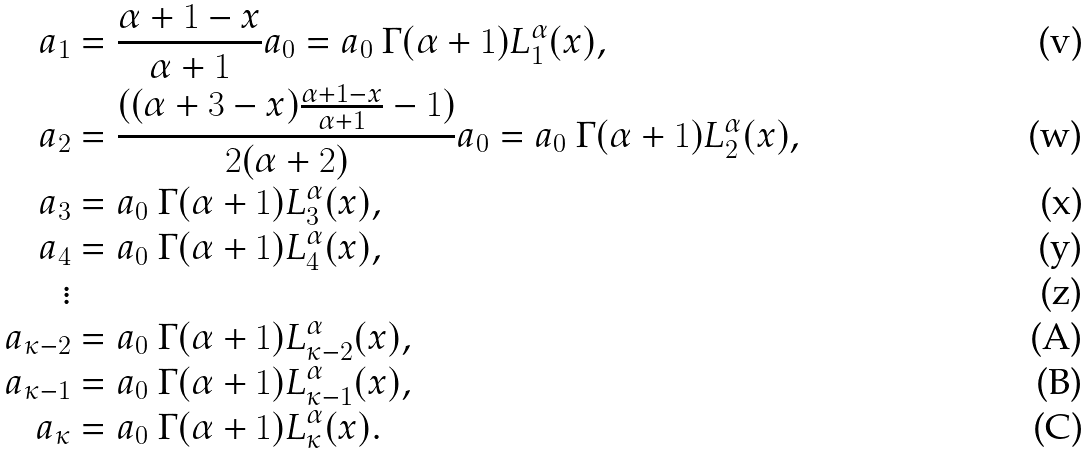<formula> <loc_0><loc_0><loc_500><loc_500>a _ { 1 } & = \frac { \alpha + 1 - x } { \alpha + 1 } a _ { 0 } = a _ { 0 } \ \Gamma ( \alpha + 1 ) L ^ { \alpha } _ { 1 } ( x ) , \\ a _ { 2 } & = \frac { ( ( \alpha + 3 - x ) \frac { \alpha + 1 - x } { \alpha + 1 } - 1 ) } { 2 ( \alpha + 2 ) } a _ { 0 } = a _ { 0 } \ \Gamma ( \alpha + 1 ) L ^ { \alpha } _ { 2 } ( x ) , \\ a _ { 3 } & = a _ { 0 } \ \Gamma ( \alpha + 1 ) L ^ { \alpha } _ { 3 } ( x ) , \\ a _ { 4 } & = a _ { 0 } \ \Gamma ( \alpha + 1 ) L ^ { \alpha } _ { 4 } ( x ) , \\ \vdots \\ a _ { \kappa - 2 } & = a _ { 0 } \ \Gamma ( \alpha + 1 ) L ^ { \alpha } _ { \kappa - 2 } ( x ) , \\ a _ { \kappa - 1 } & = a _ { 0 } \ \Gamma ( \alpha + 1 ) L ^ { \alpha } _ { \kappa - 1 } ( x ) , \\ a _ { \kappa } & = a _ { 0 } \ \Gamma ( \alpha + 1 ) L ^ { \alpha } _ { \kappa } ( x ) .</formula> 